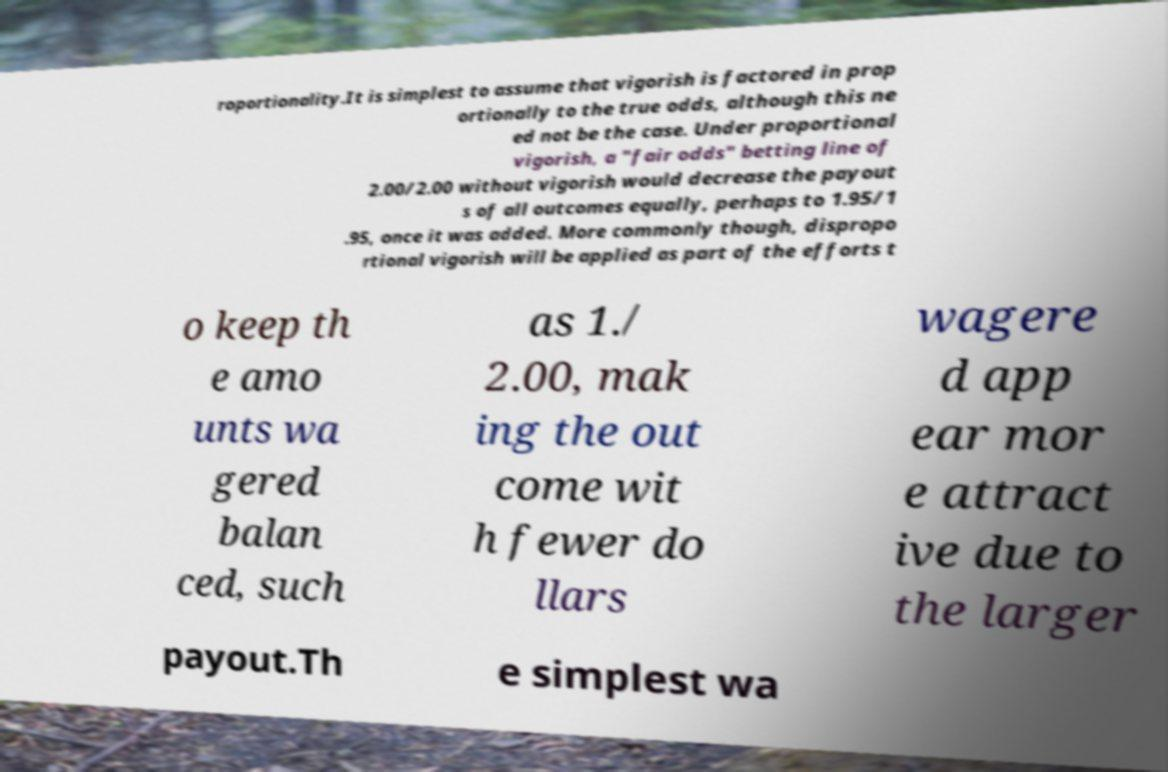For documentation purposes, I need the text within this image transcribed. Could you provide that? roportionality.It is simplest to assume that vigorish is factored in prop ortionally to the true odds, although this ne ed not be the case. Under proportional vigorish, a "fair odds" betting line of 2.00/2.00 without vigorish would decrease the payout s of all outcomes equally, perhaps to 1.95/1 .95, once it was added. More commonly though, dispropo rtional vigorish will be applied as part of the efforts t o keep th e amo unts wa gered balan ced, such as 1./ 2.00, mak ing the out come wit h fewer do llars wagere d app ear mor e attract ive due to the larger payout.Th e simplest wa 